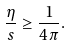Convert formula to latex. <formula><loc_0><loc_0><loc_500><loc_500>\frac { \eta } { s } \geq \frac { 1 } { 4 \pi } .</formula> 